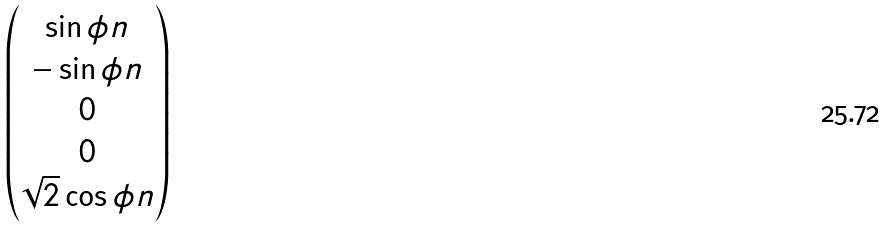<formula> <loc_0><loc_0><loc_500><loc_500>\begin{pmatrix} \sin \phi n \\ - \sin \phi n \\ 0 \\ 0 \\ \sqrt { 2 } \cos \phi n \end{pmatrix}</formula> 